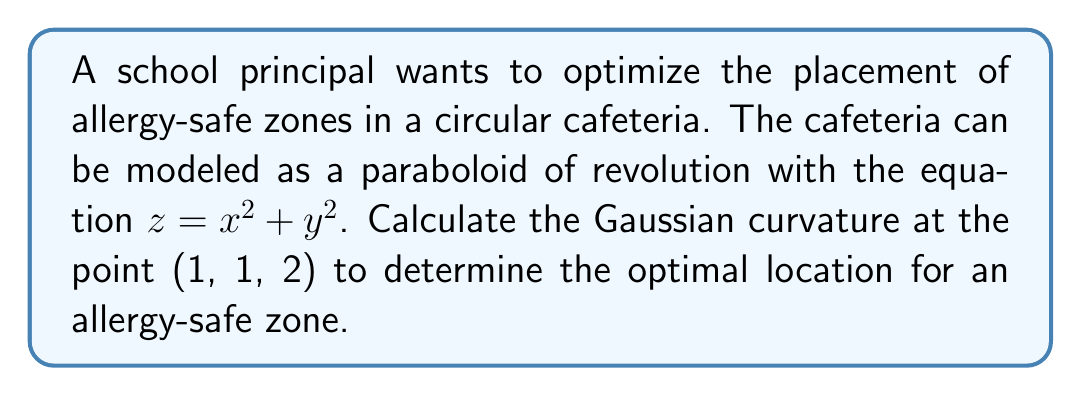Show me your answer to this math problem. To calculate the Gaussian curvature of the paraboloid at the point (1, 1, 2), we'll follow these steps:

1) The paraboloid is given by the equation $z = x^2 + y^2$. We can represent this as a parametric surface:

   $r(u, v) = (u, v, u^2 + v^2)$

2) We need to calculate the first and second fundamental forms. Let's start with the partial derivatives:

   $r_u = (1, 0, 2u)$
   $r_v = (0, 1, 2v)$
   $r_{uu} = (0, 0, 2)$
   $r_{vv} = (0, 0, 2)$
   $r_{uv} = (0, 0, 0)$

3) The coefficients of the first fundamental form are:

   $E = r_u \cdot r_u = 1 + 4u^2$
   $F = r_u \cdot r_v = 4uv$
   $G = r_v \cdot r_v = 1 + 4v^2$

4) The unit normal vector is:

   $N = \frac{r_u \times r_v}{|r_u \times r_v|} = \frac{(-2u, -2v, 1)}{\sqrt{1 + 4u^2 + 4v^2}}$

5) The coefficients of the second fundamental form are:

   $e = r_{uu} \cdot N = \frac{2}{\sqrt{1 + 4u^2 + 4v^2}}$
   $f = r_{uv} \cdot N = 0$
   $g = r_{vv} \cdot N = \frac{2}{\sqrt{1 + 4u^2 + 4v^2}}$

6) The Gaussian curvature K is given by:

   $K = \frac{eg - f^2}{EG - F^2}$

7) Substituting the values at the point (1, 1, 2):

   $K = \frac{(\frac{2}{\sqrt{9}})(\frac{2}{\sqrt{9}}) - 0^2}{(5)(5) - (4)^2} = \frac{4/9}{25 - 16} = \frac{4/9}{9} = \frac{4}{81}$

Therefore, the Gaussian curvature at the point (1, 1, 2) is $\frac{4}{81}$.
Answer: $\frac{4}{81}$ 